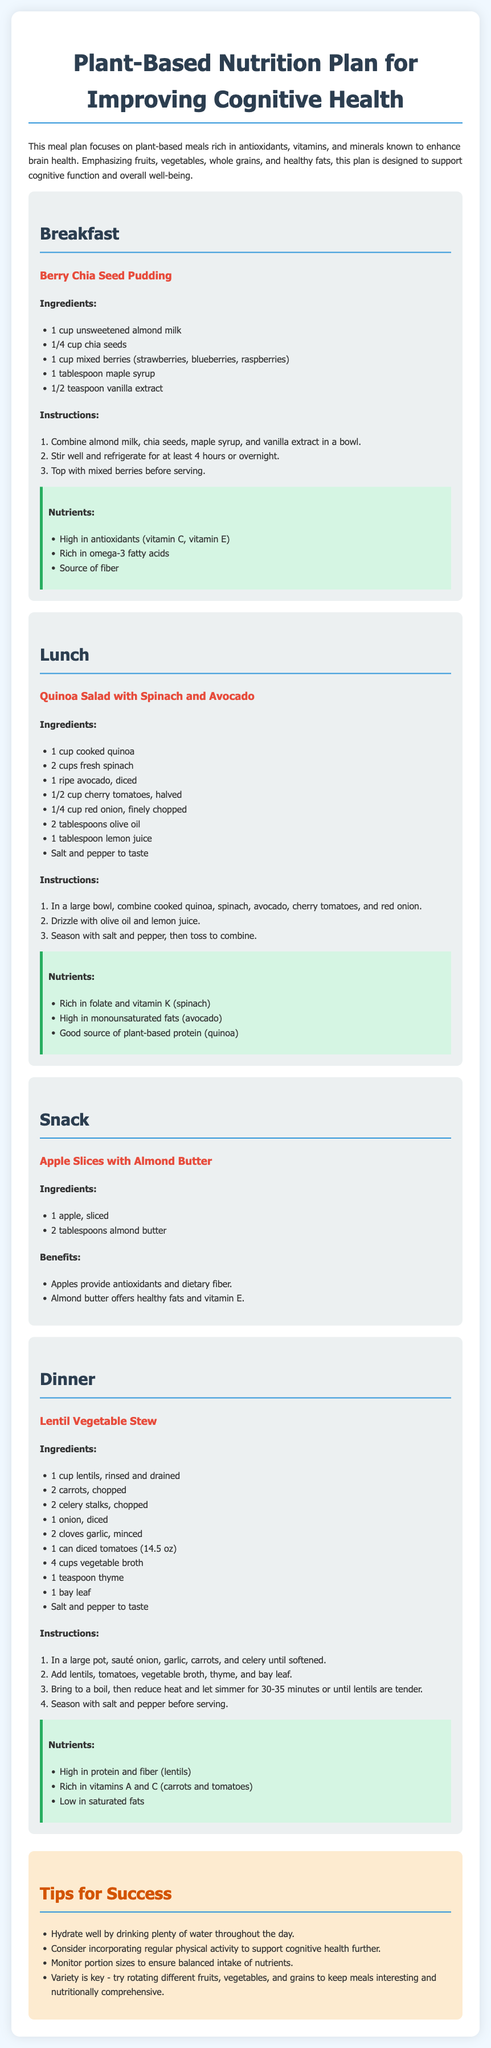What is the main goal of this meal plan? The meal plan focuses on plant-based meals rich in antioxidants, vitamins, and minerals known to enhance brain health.
Answer: Enhancing brain health What is the ingredient that provides healthy fats in the Quinoa Salad? Avocado is mentioned as a key ingredient providing healthy fats in the Quinoa Salad.
Answer: Avocado How long should the Berry Chia Seed Pudding be refrigerated? The instructions state that the Berry Chia Seed Pudding needs to be refrigerated for at least 4 hours or overnight.
Answer: 4 hours What nutrient is high in the Lentil Vegetable Stew? The Nutrients section indicates that the Lentil Vegetable Stew is high in protein and fiber.
Answer: Protein and fiber How many tablespoons of olive oil are used in the Quinoa Salad? The recipe states that 2 tablespoons of olive oil are used in the Quinoa Salad.
Answer: 2 tablespoons What fruit is paired with almond butter in the snack? The meal plan lists sliced apple as the fruit paired with almond butter.
Answer: Apple What type of meal is "Lentil Vegetable Stew"? The document categorizes "Lentil Vegetable Stew" as a dinner meal.
Answer: Dinner Which vitamin is high in the Berry Chia Seed Pudding? The nutrients list for Berry Chia Seed Pudding mentions it is high in vitamin E among others.
Answer: Vitamin E What is one tip for success mentioned in the document? The tips include "Hydrate well by drinking plenty of water throughout the day."
Answer: Hydrate well 